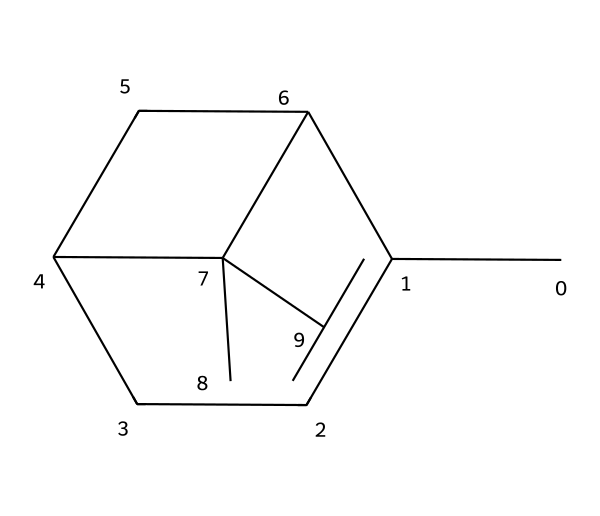What is the molecular formula of pinene? To derive the molecular formula from the SMILES notation, we count the number of carbon (C) and hydrogen (H) atoms present in the structure. The SMILES representation indicates 10 carbon atoms and 16 hydrogen atoms. Thus, the molecular formula is C10H16.
Answer: C10H16 How many rings are present in the structure? By examining the connections in the chemical structure, we identify that there are two cyclic parts where atoms are bonded in a ring formation. Therefore, the total number of rings present is two.
Answer: 2 What type of compound is pinene classified as? Pinene is characterized by its molecular structure and specific functional groups. Given its structure lacks any functional groups typically associated with alcohols or phenols and has a hydrocarbon nature, it is classified as a terpene.
Answer: terpene Which functional group is absent in pinene that is common in other organic compounds? Looking at the chemical structure, we note that there are no oxygen atoms or any functional group containing oxygen, such as hydroxyl or carbonyl groups. This absence distinguishes it from many organic compounds that include such functional groups.
Answer: hydroxyl What is the degree of unsaturation of pinene? The degree of unsaturation is calculated based on the number of rings and double bonds in the structure. Pinene has two rings (which contribute one degree of unsaturation each) and one double bond, leading to a total degree of unsaturation of 3.
Answer: 3 How does the structure of pinene contribute to its scent? Analyzing the structure reveals that pinene consists of multiple carbon atoms creating a complex arrangement that allows for the formation of distinct aromatic properties. This unique arrangement is responsible for its characteristic pine-like scent.
Answer: aromatic properties Is pinene considered biodegradable? Given its natural occurrence and non-toxic composition as derived from plant sources, pinene can be classified as biodegradable, allowing it to break down in environmental conditions effectively.
Answer: biodegradable 